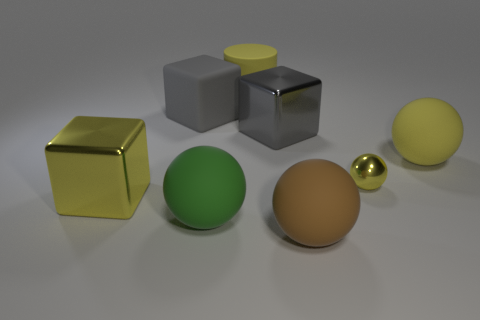How many yellow balls must be subtracted to get 1 yellow balls? 1 Subtract all blocks. How many objects are left? 5 Subtract 1 blocks. How many blocks are left? 2 Subtract all green cylinders. Subtract all red blocks. How many cylinders are left? 1 Subtract all red blocks. How many green spheres are left? 1 Subtract all large matte spheres. Subtract all big brown shiny cylinders. How many objects are left? 5 Add 1 big yellow balls. How many big yellow balls are left? 2 Add 8 brown matte things. How many brown matte things exist? 9 Add 2 big spheres. How many objects exist? 10 Subtract all brown balls. How many balls are left? 3 